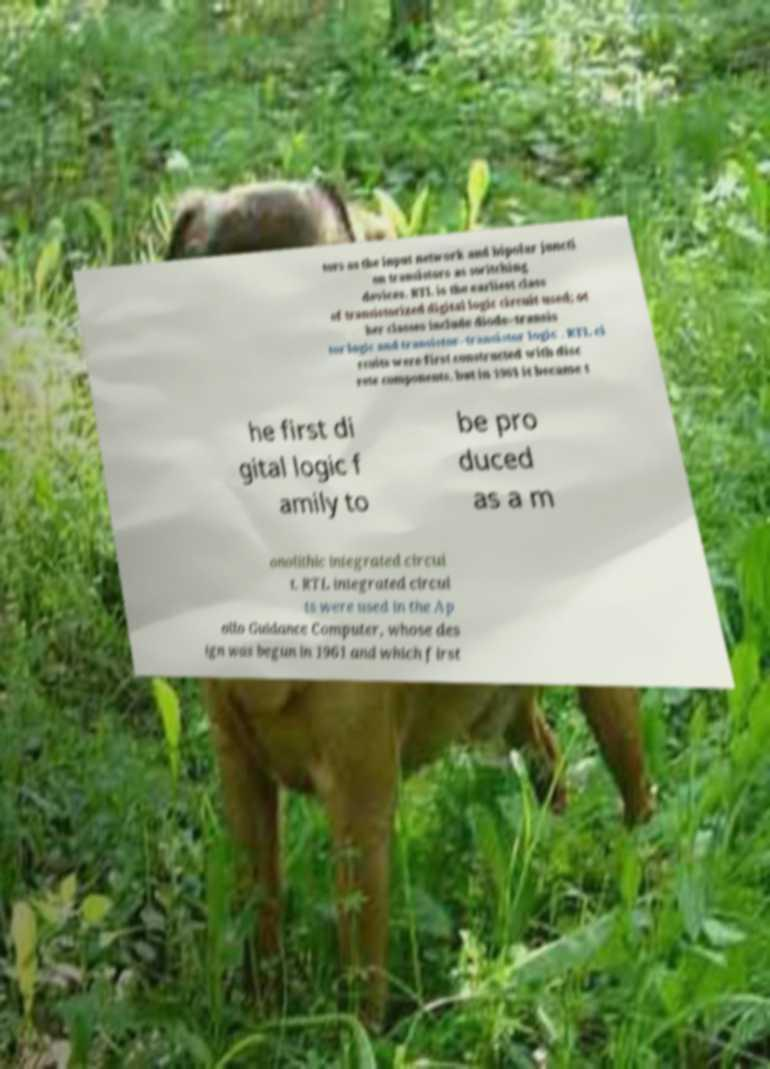Please read and relay the text visible in this image. What does it say? tors as the input network and bipolar juncti on transistors as switching devices. RTL is the earliest class of transistorized digital logic circuit used; ot her classes include diode–transis tor logic and transistor–transistor logic . RTL ci rcuits were first constructed with disc rete components, but in 1961 it became t he first di gital logic f amily to be pro duced as a m onolithic integrated circui t. RTL integrated circui ts were used in the Ap ollo Guidance Computer, whose des ign was begun in 1961 and which first 